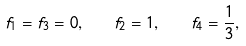Convert formula to latex. <formula><loc_0><loc_0><loc_500><loc_500>f _ { 1 } = f _ { 3 } = 0 , \quad f _ { 2 } = 1 , \quad f _ { 4 } = \frac { 1 } { 3 } ,</formula> 